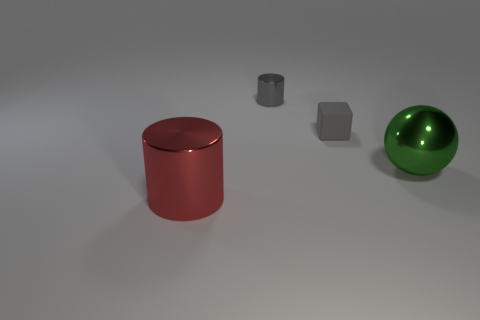Are there any other things that have the same color as the tiny rubber cube?
Your answer should be compact. Yes. There is a gray object to the right of the metallic cylinder to the right of the large metal thing on the left side of the tiny gray cube; what is its size?
Keep it short and to the point. Small. What is the color of the metallic thing that is in front of the gray matte block and left of the tiny gray matte cube?
Provide a short and direct response. Red. There is a thing that is in front of the green shiny sphere; what size is it?
Your answer should be compact. Large. How many other blocks have the same material as the block?
Offer a very short reply. 0. What is the shape of the small object that is the same color as the tiny metal cylinder?
Your response must be concise. Cube. There is a small object that is left of the gray matte object; is its shape the same as the big green thing?
Ensure brevity in your answer.  No. The tiny cylinder that is made of the same material as the green sphere is what color?
Your response must be concise. Gray. There is a gray thing that is in front of the metal cylinder behind the green metal thing; is there a large object on the left side of it?
Make the answer very short. Yes. What is the shape of the tiny gray rubber thing?
Your answer should be very brief. Cube. 